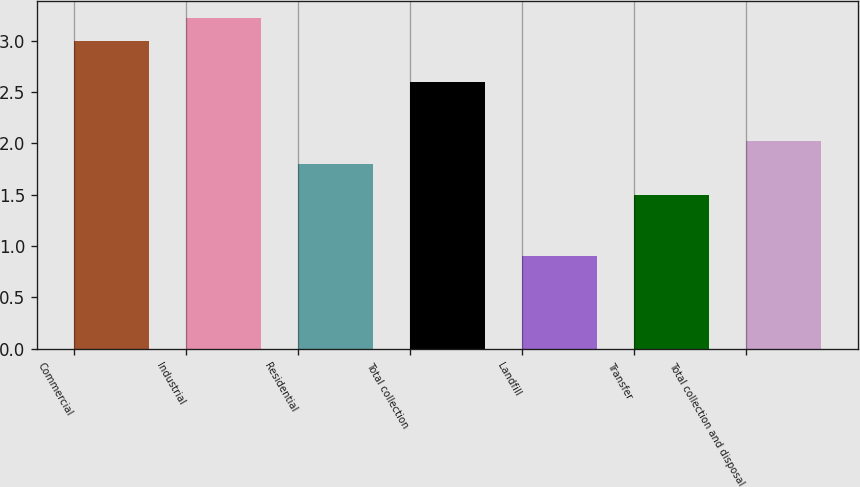Convert chart. <chart><loc_0><loc_0><loc_500><loc_500><bar_chart><fcel>Commercial<fcel>Industrial<fcel>Residential<fcel>Total collection<fcel>Landfill<fcel>Transfer<fcel>Total collection and disposal<nl><fcel>3<fcel>3.22<fcel>1.8<fcel>2.6<fcel>0.9<fcel>1.5<fcel>2.02<nl></chart> 